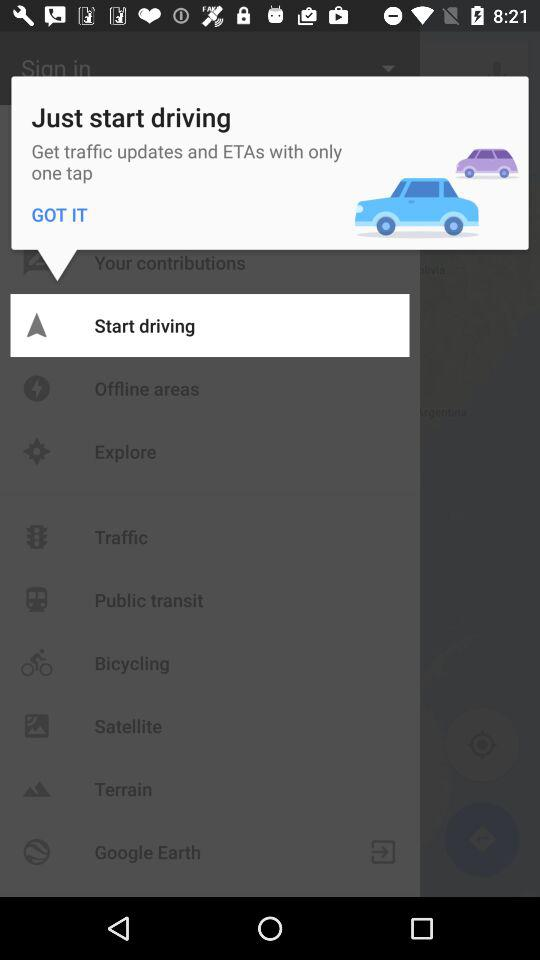Which option has been selected?
When the provided information is insufficient, respond with <no answer>. <no answer> 